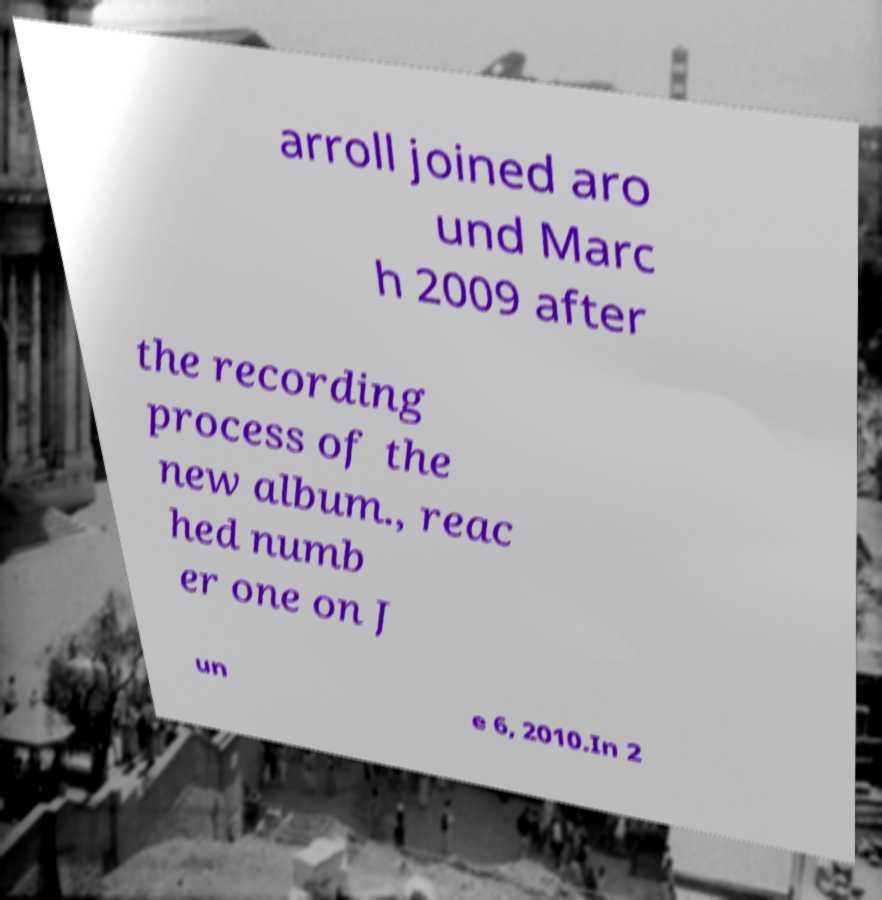Please identify and transcribe the text found in this image. arroll joined aro und Marc h 2009 after the recording process of the new album., reac hed numb er one on J un e 6, 2010.In 2 